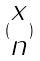<formula> <loc_0><loc_0><loc_500><loc_500>( \begin{matrix} x \\ n \end{matrix} )</formula> 